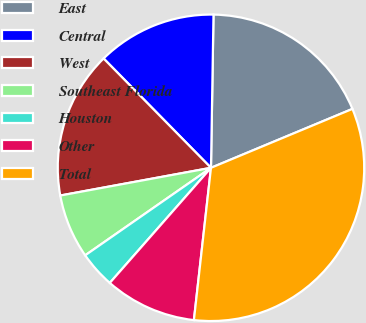Convert chart. <chart><loc_0><loc_0><loc_500><loc_500><pie_chart><fcel>East<fcel>Central<fcel>West<fcel>Southeast Florida<fcel>Houston<fcel>Other<fcel>Total<nl><fcel>18.46%<fcel>12.62%<fcel>15.54%<fcel>6.78%<fcel>3.85%<fcel>9.7%<fcel>33.06%<nl></chart> 